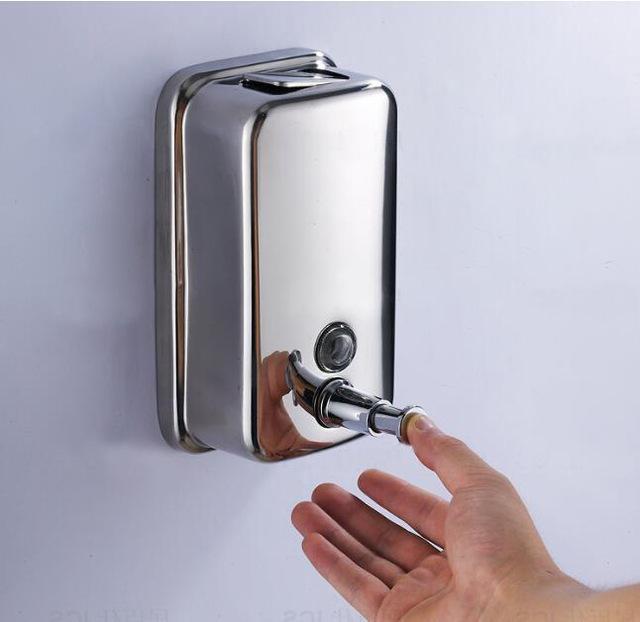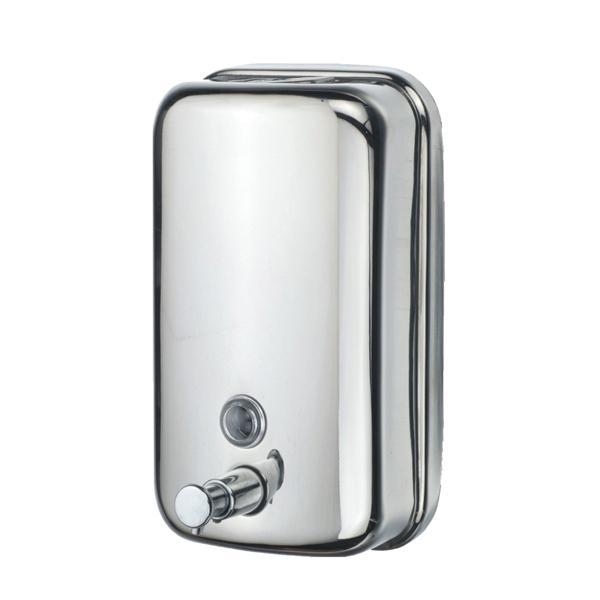The first image is the image on the left, the second image is the image on the right. Given the left and right images, does the statement "There are exactly two all metal dispensers." hold true? Answer yes or no. Yes. The first image is the image on the left, the second image is the image on the right. Considering the images on both sides, is "there is a soap dispenser with a thumb pushing the dispenser plunger" valid? Answer yes or no. Yes. 